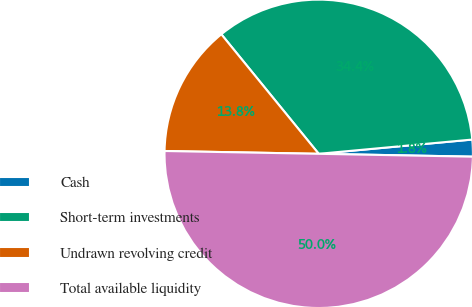Convert chart. <chart><loc_0><loc_0><loc_500><loc_500><pie_chart><fcel>Cash<fcel>Short-term investments<fcel>Undrawn revolving credit<fcel>Total available liquidity<nl><fcel>1.77%<fcel>34.41%<fcel>13.83%<fcel>50.0%<nl></chart> 